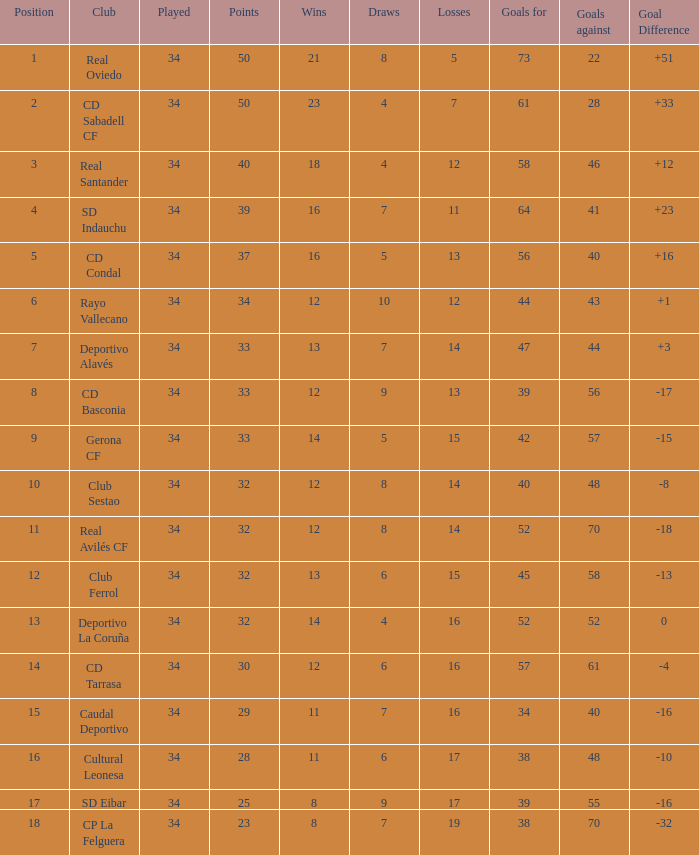Which Played has Draws smaller than 7, and Goals for smaller than 61, and Goals against smaller than 48, and a Position of 5? 34.0. 